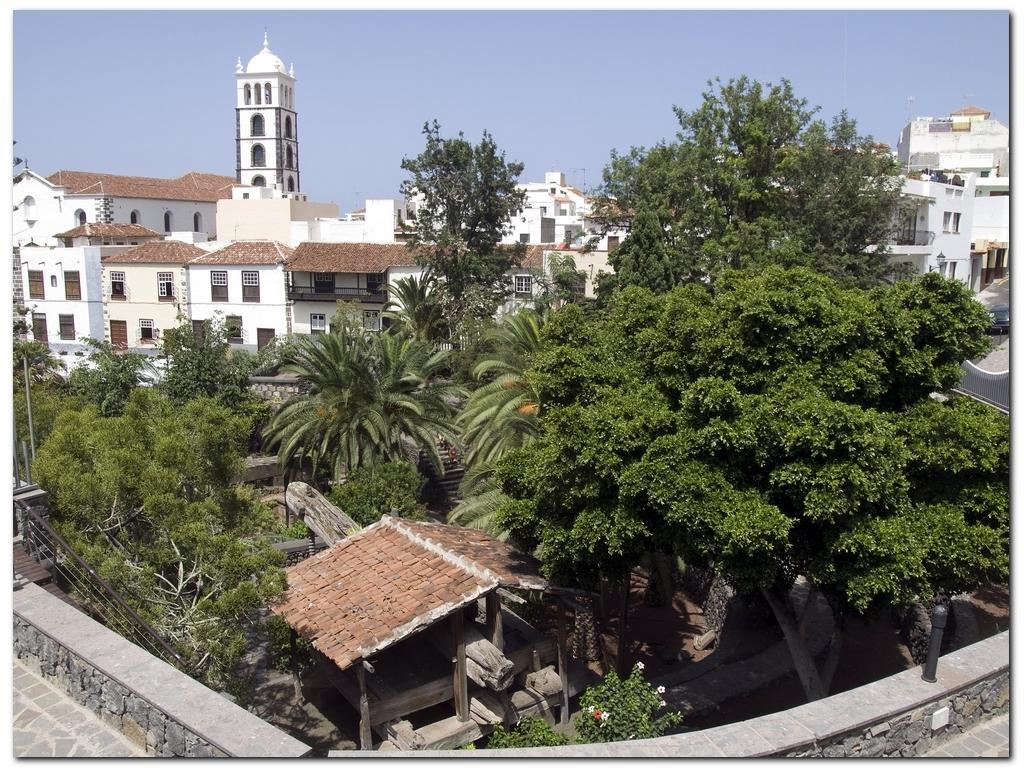What type of natural elements can be seen in the image? There are trees in the image. What type of structures are present in the image? There are buildings with windows in the image. Where are the buildings located in relation to the ground? The buildings are on the ground. What is visible in the background of the image? The sky is visible in the background of the image. What color is the sky in the image? The sky is blue in the image. Can you tell me how many people are in the group reading a book in the image? There is no group of people reading a book in the image; it features trees, buildings, and a blue sky. What type of impulse can be seen affecting the trees in the image? There is no impulse affecting the trees in the image; they are stationary and not moving. 